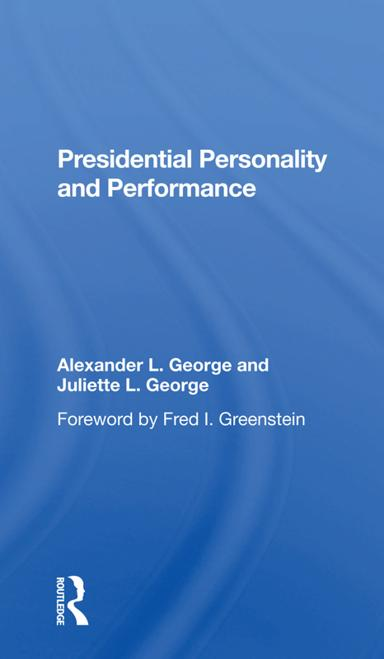What methodologies do the authors use to assess presidential performance in the book? The authors, Alexander L. George and Juliette L. George, utilize a blend of psychological analysis and historical case studies to evaluate how various presidents have handled major policies and crises during their tenures. 